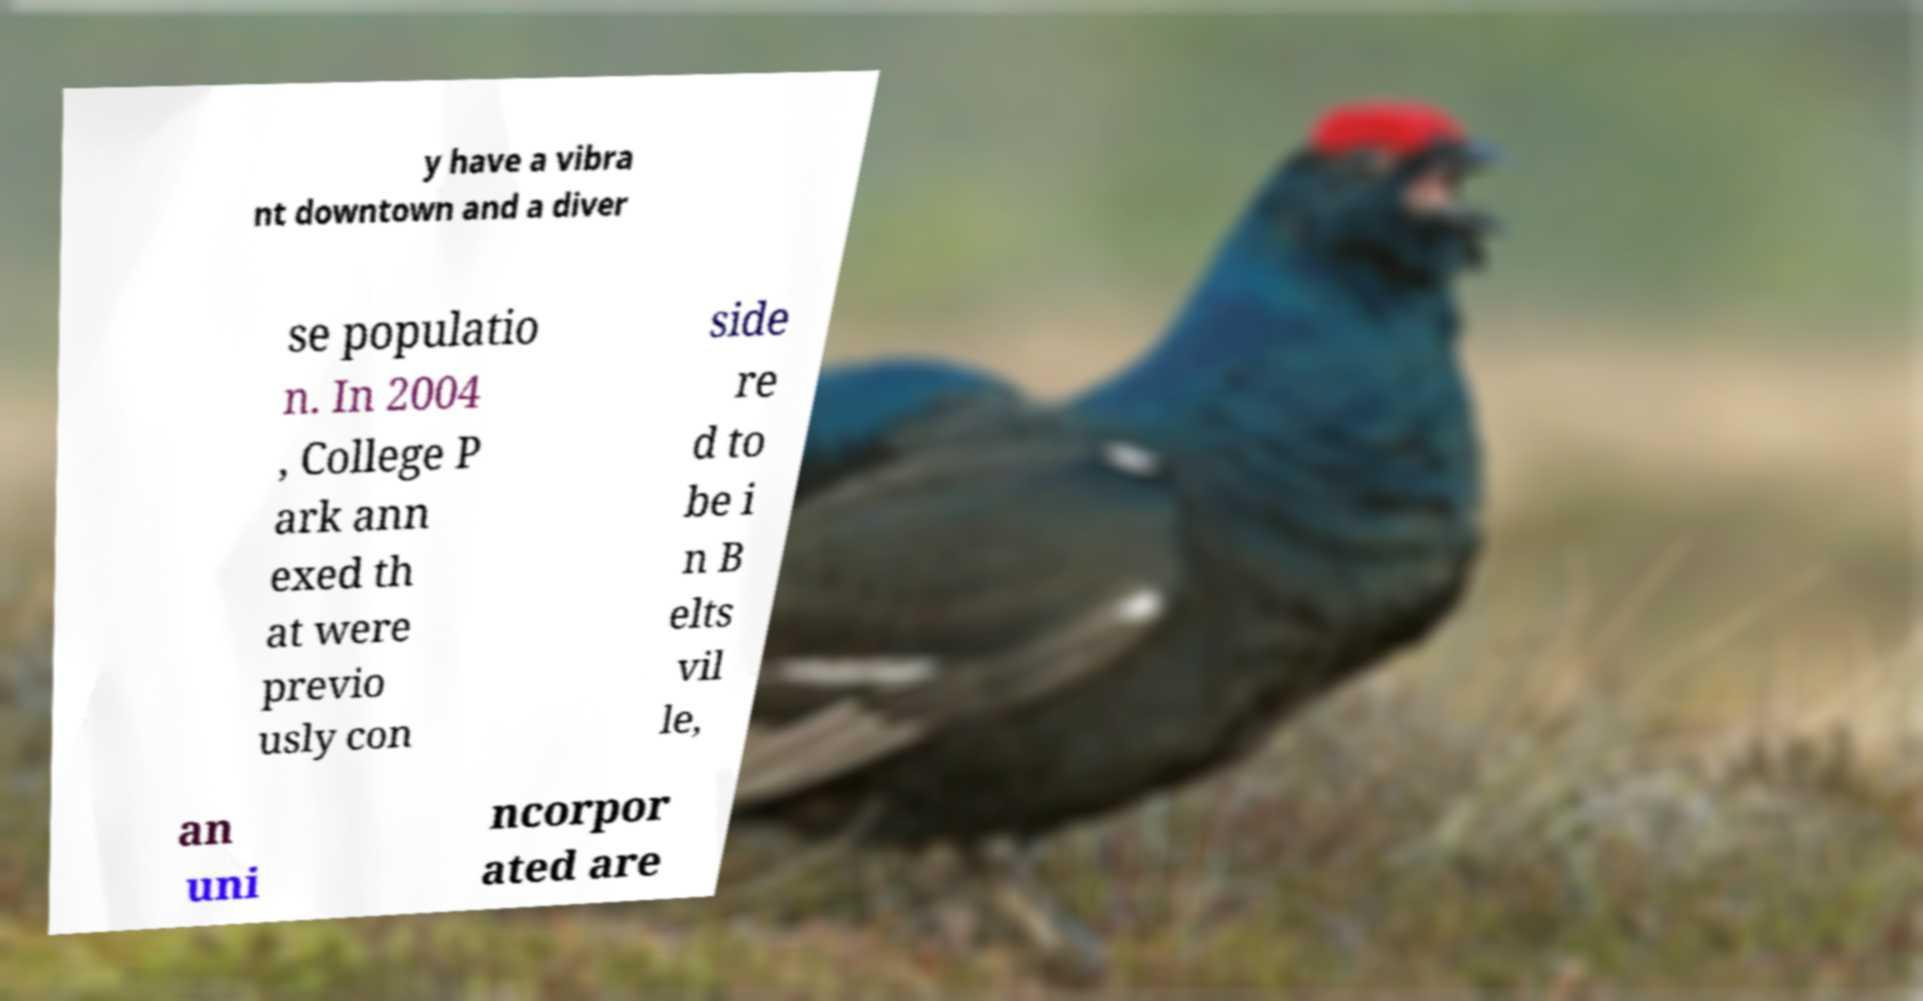There's text embedded in this image that I need extracted. Can you transcribe it verbatim? y have a vibra nt downtown and a diver se populatio n. In 2004 , College P ark ann exed th at were previo usly con side re d to be i n B elts vil le, an uni ncorpor ated are 